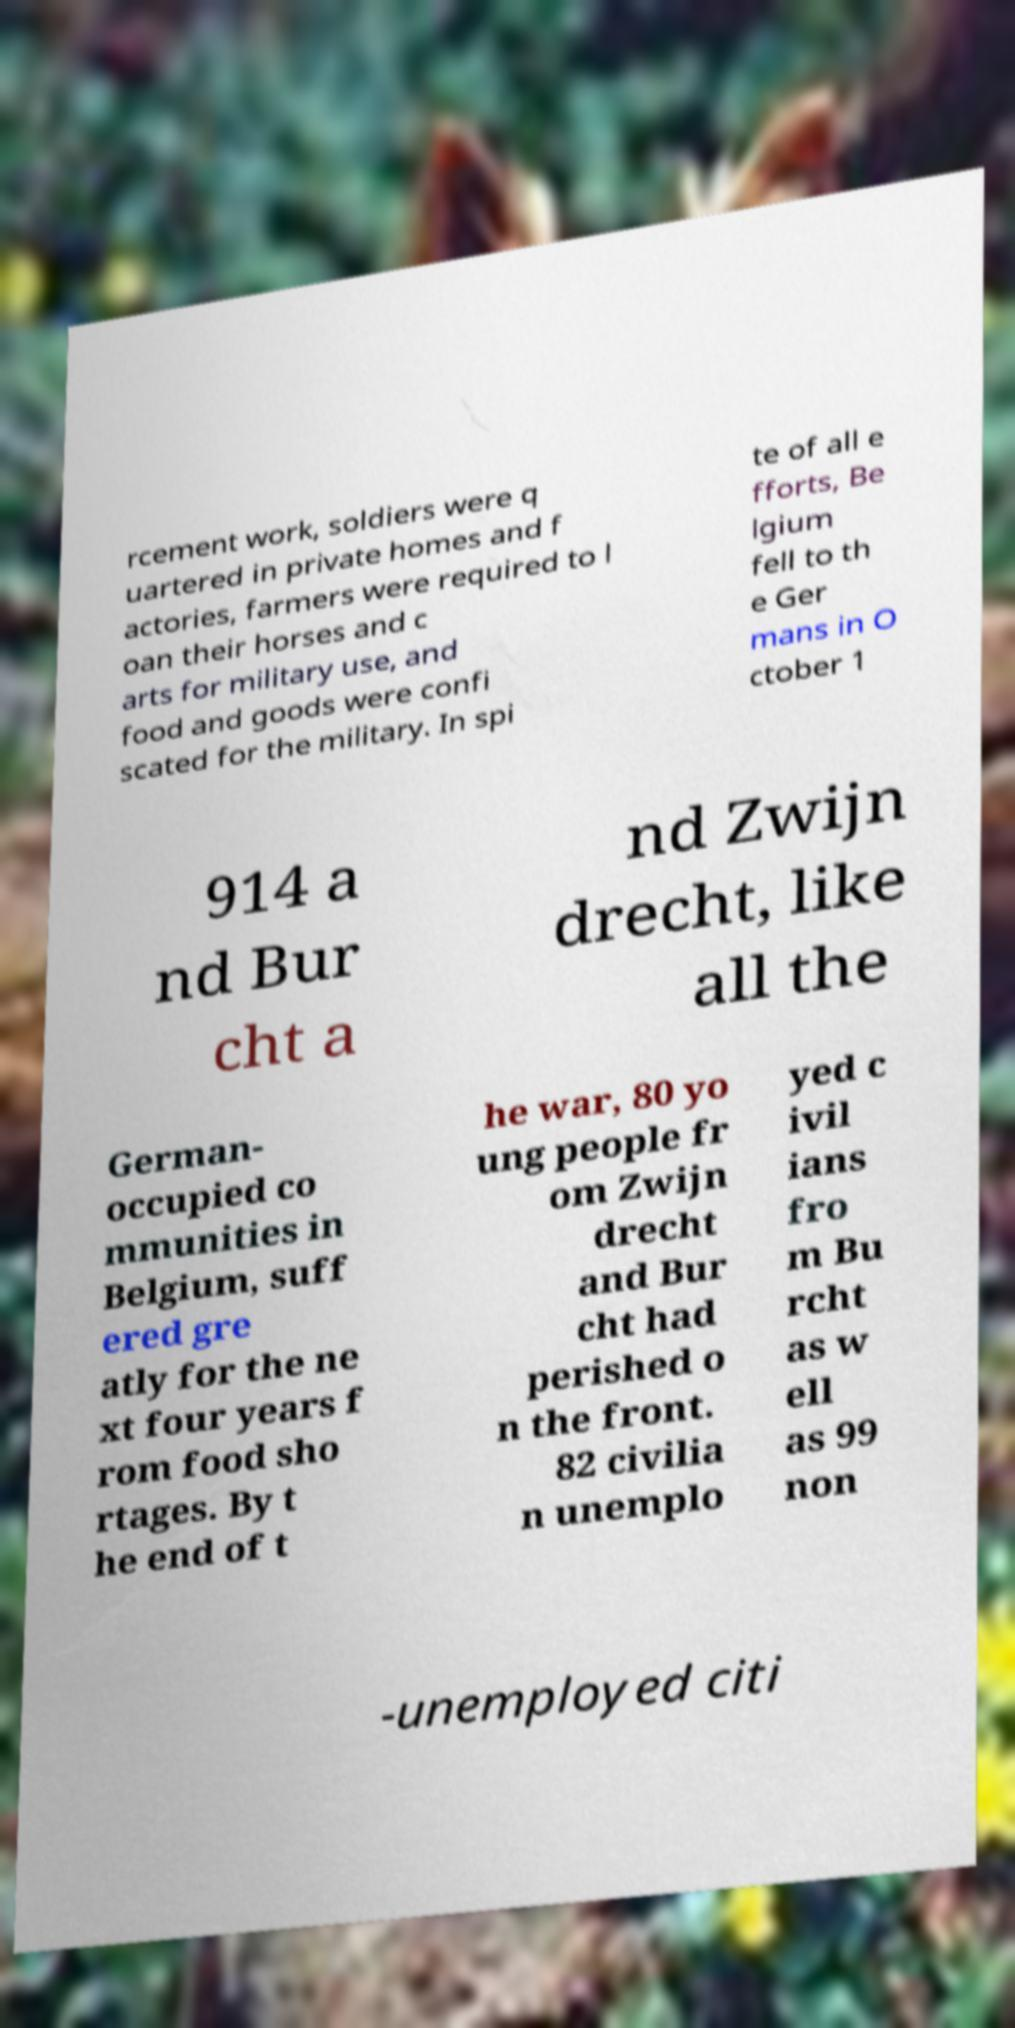For documentation purposes, I need the text within this image transcribed. Could you provide that? rcement work, soldiers were q uartered in private homes and f actories, farmers were required to l oan their horses and c arts for military use, and food and goods were confi scated for the military. In spi te of all e fforts, Be lgium fell to th e Ger mans in O ctober 1 914 a nd Bur cht a nd Zwijn drecht, like all the German- occupied co mmunities in Belgium, suff ered gre atly for the ne xt four years f rom food sho rtages. By t he end of t he war, 80 yo ung people fr om Zwijn drecht and Bur cht had perished o n the front. 82 civilia n unemplo yed c ivil ians fro m Bu rcht as w ell as 99 non -unemployed citi 